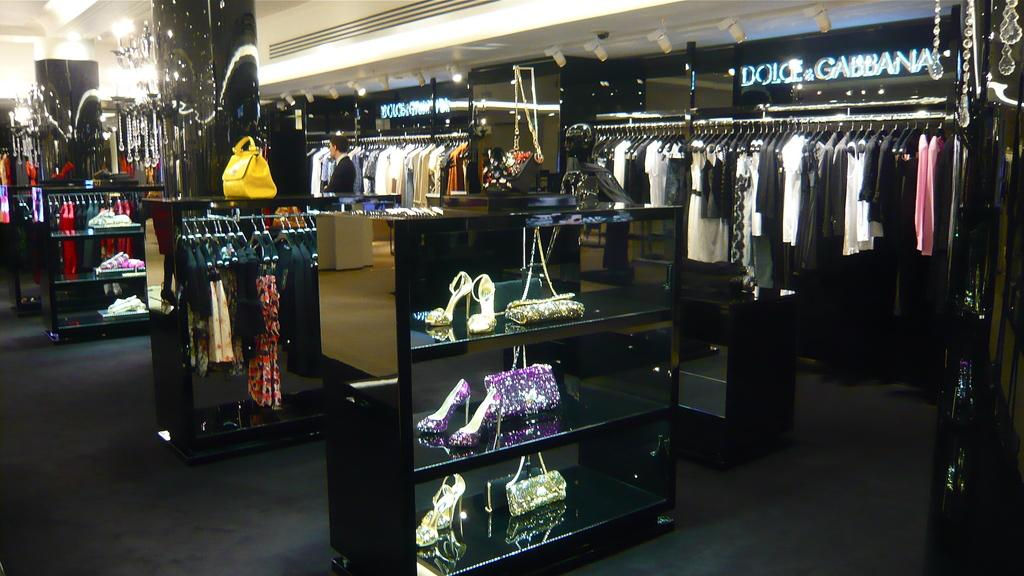What type of establishment is depicted in the image? The image shows an inner view of a store. What types of items can be found in the store? There are clothes, footwear, and wallets in the store. Can you describe the man standing in the store? There is a man standing in the store, but no specific details about his appearance or actions are provided. What is the lighting situation in the store? There is lighting in the store. How are the items in the store organized? There are shelves in the store, which suggests that the items are organized on these shelves. How many hydrants are visible in the store? There are no hydrants present in the store; it is an indoor establishment selling clothes, footwear, and wallets. 